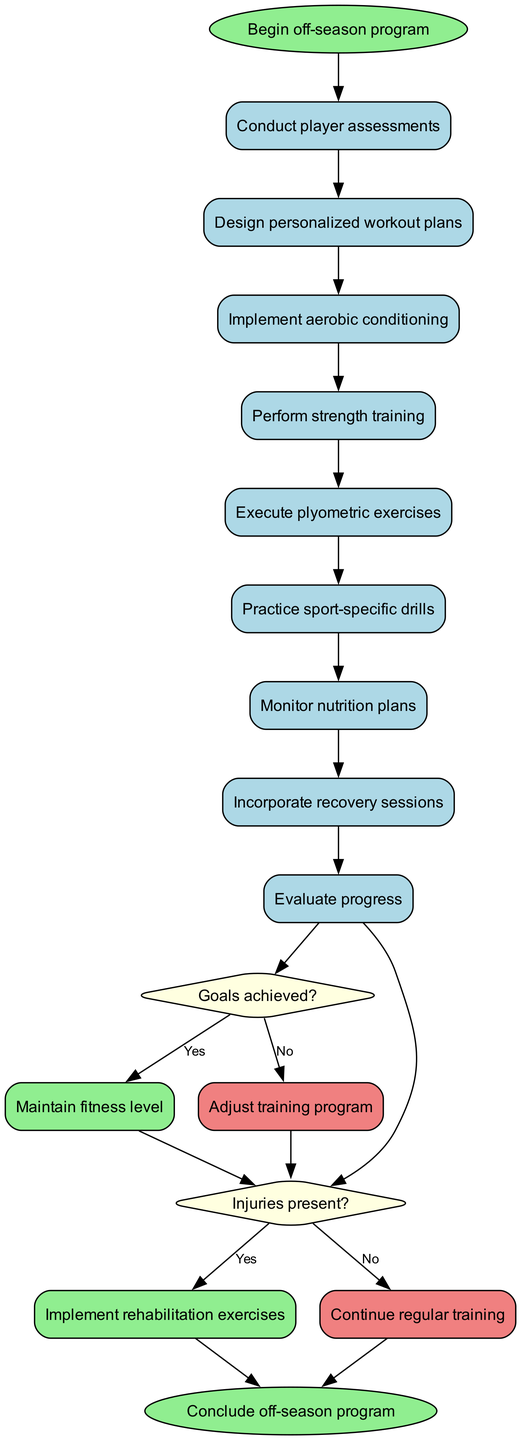What is the start node in the diagram? The start node in the diagram is identified at the beginning of the flow and is labeled "Begin off-season program."
Answer: Begin off-season program How many activities are listed in the diagram? By counting the activities presented in the list, we find there are a total of 9 activities included in the flow.
Answer: 9 What happens if injuries are present? Referring to the decision node regarding injuries, if injuries are present, the next action is to "Implement rehabilitation exercises."
Answer: Implement rehabilitation exercises What is the last activity before the first decision? The last activity before the first decision can be determined by following the activity flow, where "Practice sport-specific drills" is the last activity before reaching the decision node.
Answer: Practice sport-specific drills What are the outcomes if goals are achieved? The outcome for achieving goals, as indicated in the decision, leads to maintaining the fitness level.
Answer: Maintain fitness level What happens if goals are not achieved? Following the decision regarding goal achievement, if goals are not achieved, the action taken is to adjust the training program.
Answer: Adjust training program Which activity comes after "Implement aerobic conditioning"? By reviewing the sequence of activities, the activity that follows "Implement aerobic conditioning" is "Perform strength training."
Answer: Perform strength training What is the end node of the diagram? The end node is found at the conclusion of the flow, marking the completion of the process, labeled "Conclude off-season program."
Answer: Conclude off-season program Where does the flow lead after "Evaluate progress" if goals are achieved? In the flow of the diagram, upon evaluating progress, if goals are achieved, it leads to maintaining the fitness level, before concluding the program.
Answer: Maintain fitness level 